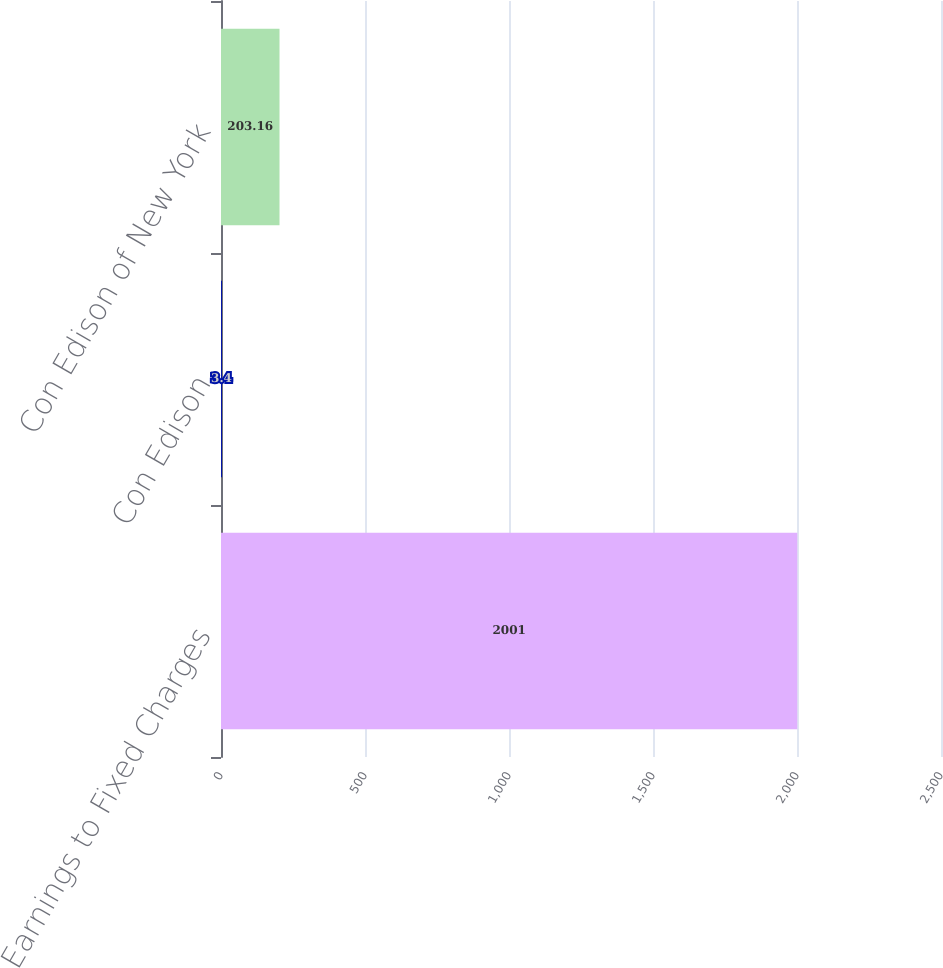Convert chart to OTSL. <chart><loc_0><loc_0><loc_500><loc_500><bar_chart><fcel>Earnings to Fixed Charges<fcel>Con Edison<fcel>Con Edison of New York<nl><fcel>2001<fcel>3.4<fcel>203.16<nl></chart> 